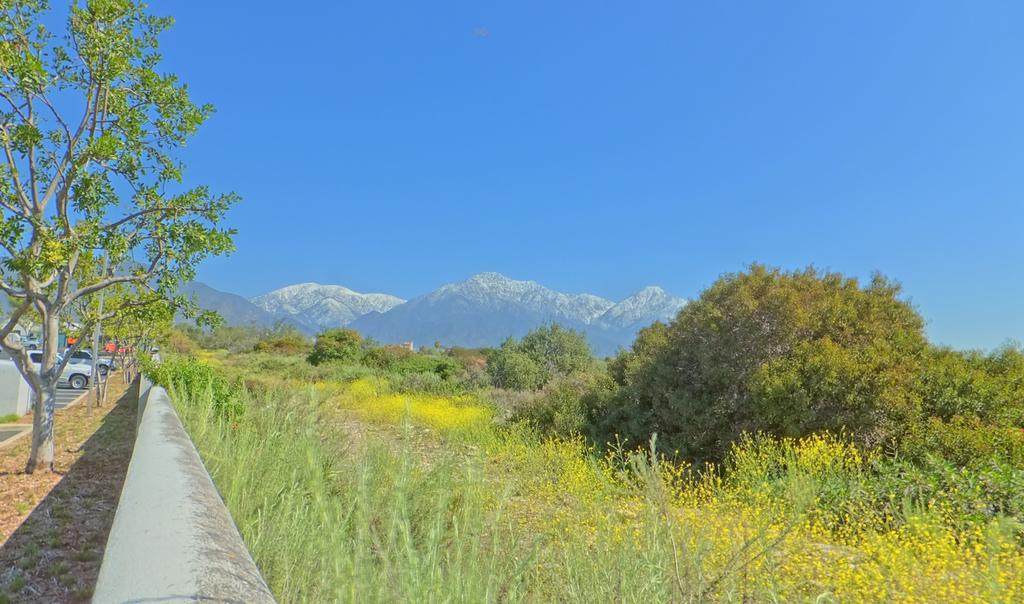What can be seen on the left side of the image? There are cars and trees on the left side of the image. What is located in the center of the image? There is a railing in the center of the image. What type of vegetation is present on the right side of the image? There are trees on the right side of the image. What natural feature is visible in the background of the image? There are mountains visible in the image. What type of ground cover is present in the image? There is grass on the ground in the image. Where is the writer sitting in the image? There is no writer present in the image. What type of plantation can be seen in the image? There is no plantation present in the image. 